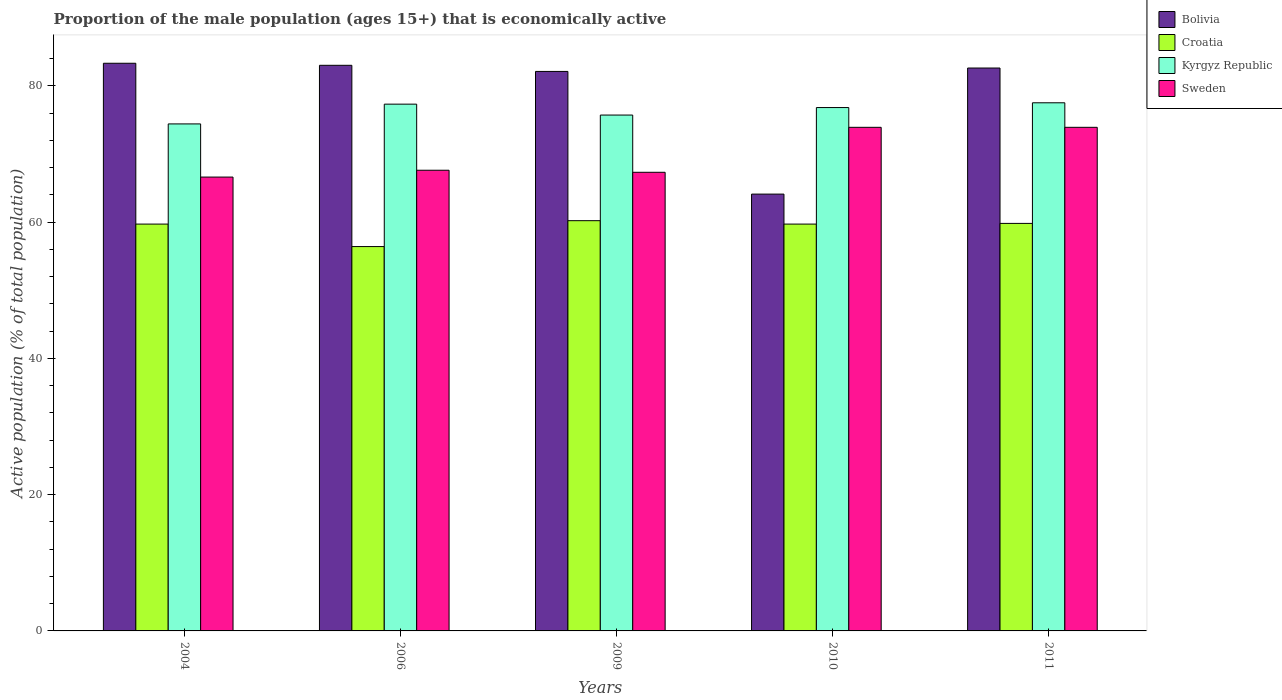How many groups of bars are there?
Offer a terse response. 5. Are the number of bars per tick equal to the number of legend labels?
Your answer should be very brief. Yes. What is the label of the 4th group of bars from the left?
Offer a terse response. 2010. In how many cases, is the number of bars for a given year not equal to the number of legend labels?
Your answer should be compact. 0. What is the proportion of the male population that is economically active in Kyrgyz Republic in 2004?
Provide a short and direct response. 74.4. Across all years, what is the maximum proportion of the male population that is economically active in Kyrgyz Republic?
Your response must be concise. 77.5. Across all years, what is the minimum proportion of the male population that is economically active in Bolivia?
Your answer should be very brief. 64.1. In which year was the proportion of the male population that is economically active in Sweden maximum?
Offer a terse response. 2010. What is the total proportion of the male population that is economically active in Sweden in the graph?
Offer a very short reply. 349.3. What is the difference between the proportion of the male population that is economically active in Bolivia in 2010 and that in 2011?
Provide a short and direct response. -18.5. What is the difference between the proportion of the male population that is economically active in Croatia in 2010 and the proportion of the male population that is economically active in Bolivia in 2009?
Your answer should be compact. -22.4. What is the average proportion of the male population that is economically active in Sweden per year?
Provide a succinct answer. 69.86. In the year 2011, what is the difference between the proportion of the male population that is economically active in Croatia and proportion of the male population that is economically active in Bolivia?
Ensure brevity in your answer.  -22.8. In how many years, is the proportion of the male population that is economically active in Croatia greater than 16 %?
Your answer should be very brief. 5. What is the ratio of the proportion of the male population that is economically active in Bolivia in 2004 to that in 2006?
Provide a succinct answer. 1. Is the difference between the proportion of the male population that is economically active in Croatia in 2004 and 2006 greater than the difference between the proportion of the male population that is economically active in Bolivia in 2004 and 2006?
Your answer should be very brief. Yes. What is the difference between the highest and the second highest proportion of the male population that is economically active in Kyrgyz Republic?
Offer a very short reply. 0.2. What is the difference between the highest and the lowest proportion of the male population that is economically active in Croatia?
Offer a very short reply. 3.8. Is it the case that in every year, the sum of the proportion of the male population that is economically active in Croatia and proportion of the male population that is economically active in Bolivia is greater than the sum of proportion of the male population that is economically active in Kyrgyz Republic and proportion of the male population that is economically active in Sweden?
Provide a succinct answer. No. What does the 3rd bar from the left in 2006 represents?
Your response must be concise. Kyrgyz Republic. What does the 3rd bar from the right in 2006 represents?
Keep it short and to the point. Croatia. Are all the bars in the graph horizontal?
Provide a short and direct response. No. How many years are there in the graph?
Provide a short and direct response. 5. Does the graph contain any zero values?
Make the answer very short. No. Where does the legend appear in the graph?
Your answer should be compact. Top right. How many legend labels are there?
Provide a succinct answer. 4. How are the legend labels stacked?
Your answer should be very brief. Vertical. What is the title of the graph?
Provide a short and direct response. Proportion of the male population (ages 15+) that is economically active. What is the label or title of the X-axis?
Provide a succinct answer. Years. What is the label or title of the Y-axis?
Make the answer very short. Active population (% of total population). What is the Active population (% of total population) of Bolivia in 2004?
Offer a terse response. 83.3. What is the Active population (% of total population) of Croatia in 2004?
Your answer should be very brief. 59.7. What is the Active population (% of total population) in Kyrgyz Republic in 2004?
Provide a short and direct response. 74.4. What is the Active population (% of total population) in Sweden in 2004?
Keep it short and to the point. 66.6. What is the Active population (% of total population) of Bolivia in 2006?
Offer a terse response. 83. What is the Active population (% of total population) of Croatia in 2006?
Your answer should be very brief. 56.4. What is the Active population (% of total population) of Kyrgyz Republic in 2006?
Offer a very short reply. 77.3. What is the Active population (% of total population) of Sweden in 2006?
Ensure brevity in your answer.  67.6. What is the Active population (% of total population) of Bolivia in 2009?
Provide a short and direct response. 82.1. What is the Active population (% of total population) in Croatia in 2009?
Your response must be concise. 60.2. What is the Active population (% of total population) of Kyrgyz Republic in 2009?
Provide a short and direct response. 75.7. What is the Active population (% of total population) in Sweden in 2009?
Provide a succinct answer. 67.3. What is the Active population (% of total population) in Bolivia in 2010?
Your answer should be very brief. 64.1. What is the Active population (% of total population) of Croatia in 2010?
Provide a succinct answer. 59.7. What is the Active population (% of total population) of Kyrgyz Republic in 2010?
Keep it short and to the point. 76.8. What is the Active population (% of total population) of Sweden in 2010?
Offer a terse response. 73.9. What is the Active population (% of total population) of Bolivia in 2011?
Ensure brevity in your answer.  82.6. What is the Active population (% of total population) of Croatia in 2011?
Your response must be concise. 59.8. What is the Active population (% of total population) of Kyrgyz Republic in 2011?
Make the answer very short. 77.5. What is the Active population (% of total population) in Sweden in 2011?
Your answer should be very brief. 73.9. Across all years, what is the maximum Active population (% of total population) of Bolivia?
Provide a short and direct response. 83.3. Across all years, what is the maximum Active population (% of total population) in Croatia?
Your answer should be very brief. 60.2. Across all years, what is the maximum Active population (% of total population) in Kyrgyz Republic?
Ensure brevity in your answer.  77.5. Across all years, what is the maximum Active population (% of total population) in Sweden?
Make the answer very short. 73.9. Across all years, what is the minimum Active population (% of total population) in Bolivia?
Your answer should be compact. 64.1. Across all years, what is the minimum Active population (% of total population) of Croatia?
Ensure brevity in your answer.  56.4. Across all years, what is the minimum Active population (% of total population) in Kyrgyz Republic?
Keep it short and to the point. 74.4. Across all years, what is the minimum Active population (% of total population) in Sweden?
Your response must be concise. 66.6. What is the total Active population (% of total population) of Bolivia in the graph?
Your answer should be compact. 395.1. What is the total Active population (% of total population) in Croatia in the graph?
Your response must be concise. 295.8. What is the total Active population (% of total population) of Kyrgyz Republic in the graph?
Ensure brevity in your answer.  381.7. What is the total Active population (% of total population) in Sweden in the graph?
Make the answer very short. 349.3. What is the difference between the Active population (% of total population) in Bolivia in 2004 and that in 2006?
Provide a short and direct response. 0.3. What is the difference between the Active population (% of total population) in Bolivia in 2004 and that in 2009?
Your answer should be very brief. 1.2. What is the difference between the Active population (% of total population) of Croatia in 2004 and that in 2009?
Offer a terse response. -0.5. What is the difference between the Active population (% of total population) of Kyrgyz Republic in 2004 and that in 2009?
Your answer should be compact. -1.3. What is the difference between the Active population (% of total population) in Bolivia in 2004 and that in 2010?
Your answer should be very brief. 19.2. What is the difference between the Active population (% of total population) of Kyrgyz Republic in 2004 and that in 2010?
Keep it short and to the point. -2.4. What is the difference between the Active population (% of total population) in Sweden in 2004 and that in 2010?
Make the answer very short. -7.3. What is the difference between the Active population (% of total population) of Croatia in 2004 and that in 2011?
Give a very brief answer. -0.1. What is the difference between the Active population (% of total population) in Croatia in 2006 and that in 2009?
Keep it short and to the point. -3.8. What is the difference between the Active population (% of total population) of Kyrgyz Republic in 2006 and that in 2010?
Your response must be concise. 0.5. What is the difference between the Active population (% of total population) of Sweden in 2006 and that in 2010?
Ensure brevity in your answer.  -6.3. What is the difference between the Active population (% of total population) in Bolivia in 2006 and that in 2011?
Your answer should be very brief. 0.4. What is the difference between the Active population (% of total population) in Kyrgyz Republic in 2006 and that in 2011?
Offer a terse response. -0.2. What is the difference between the Active population (% of total population) of Sweden in 2006 and that in 2011?
Offer a very short reply. -6.3. What is the difference between the Active population (% of total population) of Bolivia in 2009 and that in 2010?
Give a very brief answer. 18. What is the difference between the Active population (% of total population) of Kyrgyz Republic in 2009 and that in 2010?
Your answer should be very brief. -1.1. What is the difference between the Active population (% of total population) in Croatia in 2009 and that in 2011?
Give a very brief answer. 0.4. What is the difference between the Active population (% of total population) in Bolivia in 2010 and that in 2011?
Offer a terse response. -18.5. What is the difference between the Active population (% of total population) in Bolivia in 2004 and the Active population (% of total population) in Croatia in 2006?
Your response must be concise. 26.9. What is the difference between the Active population (% of total population) of Bolivia in 2004 and the Active population (% of total population) of Kyrgyz Republic in 2006?
Provide a succinct answer. 6. What is the difference between the Active population (% of total population) of Bolivia in 2004 and the Active population (% of total population) of Sweden in 2006?
Offer a terse response. 15.7. What is the difference between the Active population (% of total population) in Croatia in 2004 and the Active population (% of total population) in Kyrgyz Republic in 2006?
Provide a short and direct response. -17.6. What is the difference between the Active population (% of total population) of Bolivia in 2004 and the Active population (% of total population) of Croatia in 2009?
Provide a short and direct response. 23.1. What is the difference between the Active population (% of total population) in Bolivia in 2004 and the Active population (% of total population) in Sweden in 2009?
Your response must be concise. 16. What is the difference between the Active population (% of total population) in Croatia in 2004 and the Active population (% of total population) in Kyrgyz Republic in 2009?
Ensure brevity in your answer.  -16. What is the difference between the Active population (% of total population) of Croatia in 2004 and the Active population (% of total population) of Sweden in 2009?
Provide a short and direct response. -7.6. What is the difference between the Active population (% of total population) in Bolivia in 2004 and the Active population (% of total population) in Croatia in 2010?
Offer a terse response. 23.6. What is the difference between the Active population (% of total population) in Bolivia in 2004 and the Active population (% of total population) in Kyrgyz Republic in 2010?
Provide a short and direct response. 6.5. What is the difference between the Active population (% of total population) in Croatia in 2004 and the Active population (% of total population) in Kyrgyz Republic in 2010?
Offer a terse response. -17.1. What is the difference between the Active population (% of total population) in Kyrgyz Republic in 2004 and the Active population (% of total population) in Sweden in 2010?
Keep it short and to the point. 0.5. What is the difference between the Active population (% of total population) of Bolivia in 2004 and the Active population (% of total population) of Croatia in 2011?
Offer a terse response. 23.5. What is the difference between the Active population (% of total population) in Bolivia in 2004 and the Active population (% of total population) in Kyrgyz Republic in 2011?
Keep it short and to the point. 5.8. What is the difference between the Active population (% of total population) of Bolivia in 2004 and the Active population (% of total population) of Sweden in 2011?
Your answer should be compact. 9.4. What is the difference between the Active population (% of total population) of Croatia in 2004 and the Active population (% of total population) of Kyrgyz Republic in 2011?
Your answer should be very brief. -17.8. What is the difference between the Active population (% of total population) of Kyrgyz Republic in 2004 and the Active population (% of total population) of Sweden in 2011?
Give a very brief answer. 0.5. What is the difference between the Active population (% of total population) in Bolivia in 2006 and the Active population (% of total population) in Croatia in 2009?
Provide a succinct answer. 22.8. What is the difference between the Active population (% of total population) in Bolivia in 2006 and the Active population (% of total population) in Sweden in 2009?
Keep it short and to the point. 15.7. What is the difference between the Active population (% of total population) of Croatia in 2006 and the Active population (% of total population) of Kyrgyz Republic in 2009?
Your answer should be very brief. -19.3. What is the difference between the Active population (% of total population) in Bolivia in 2006 and the Active population (% of total population) in Croatia in 2010?
Keep it short and to the point. 23.3. What is the difference between the Active population (% of total population) in Bolivia in 2006 and the Active population (% of total population) in Sweden in 2010?
Your answer should be very brief. 9.1. What is the difference between the Active population (% of total population) of Croatia in 2006 and the Active population (% of total population) of Kyrgyz Republic in 2010?
Your answer should be very brief. -20.4. What is the difference between the Active population (% of total population) of Croatia in 2006 and the Active population (% of total population) of Sweden in 2010?
Your answer should be compact. -17.5. What is the difference between the Active population (% of total population) in Kyrgyz Republic in 2006 and the Active population (% of total population) in Sweden in 2010?
Give a very brief answer. 3.4. What is the difference between the Active population (% of total population) of Bolivia in 2006 and the Active population (% of total population) of Croatia in 2011?
Your answer should be very brief. 23.2. What is the difference between the Active population (% of total population) of Bolivia in 2006 and the Active population (% of total population) of Kyrgyz Republic in 2011?
Provide a succinct answer. 5.5. What is the difference between the Active population (% of total population) in Bolivia in 2006 and the Active population (% of total population) in Sweden in 2011?
Give a very brief answer. 9.1. What is the difference between the Active population (% of total population) of Croatia in 2006 and the Active population (% of total population) of Kyrgyz Republic in 2011?
Give a very brief answer. -21.1. What is the difference between the Active population (% of total population) in Croatia in 2006 and the Active population (% of total population) in Sweden in 2011?
Give a very brief answer. -17.5. What is the difference between the Active population (% of total population) of Kyrgyz Republic in 2006 and the Active population (% of total population) of Sweden in 2011?
Give a very brief answer. 3.4. What is the difference between the Active population (% of total population) in Bolivia in 2009 and the Active population (% of total population) in Croatia in 2010?
Offer a terse response. 22.4. What is the difference between the Active population (% of total population) of Bolivia in 2009 and the Active population (% of total population) of Kyrgyz Republic in 2010?
Your response must be concise. 5.3. What is the difference between the Active population (% of total population) of Bolivia in 2009 and the Active population (% of total population) of Sweden in 2010?
Your response must be concise. 8.2. What is the difference between the Active population (% of total population) in Croatia in 2009 and the Active population (% of total population) in Kyrgyz Republic in 2010?
Ensure brevity in your answer.  -16.6. What is the difference between the Active population (% of total population) of Croatia in 2009 and the Active population (% of total population) of Sweden in 2010?
Give a very brief answer. -13.7. What is the difference between the Active population (% of total population) in Bolivia in 2009 and the Active population (% of total population) in Croatia in 2011?
Offer a terse response. 22.3. What is the difference between the Active population (% of total population) in Croatia in 2009 and the Active population (% of total population) in Kyrgyz Republic in 2011?
Your response must be concise. -17.3. What is the difference between the Active population (% of total population) in Croatia in 2009 and the Active population (% of total population) in Sweden in 2011?
Offer a terse response. -13.7. What is the difference between the Active population (% of total population) in Kyrgyz Republic in 2009 and the Active population (% of total population) in Sweden in 2011?
Your answer should be compact. 1.8. What is the difference between the Active population (% of total population) of Bolivia in 2010 and the Active population (% of total population) of Croatia in 2011?
Keep it short and to the point. 4.3. What is the difference between the Active population (% of total population) in Bolivia in 2010 and the Active population (% of total population) in Kyrgyz Republic in 2011?
Your answer should be compact. -13.4. What is the difference between the Active population (% of total population) in Bolivia in 2010 and the Active population (% of total population) in Sweden in 2011?
Keep it short and to the point. -9.8. What is the difference between the Active population (% of total population) in Croatia in 2010 and the Active population (% of total population) in Kyrgyz Republic in 2011?
Your response must be concise. -17.8. What is the difference between the Active population (% of total population) in Croatia in 2010 and the Active population (% of total population) in Sweden in 2011?
Give a very brief answer. -14.2. What is the average Active population (% of total population) of Bolivia per year?
Your answer should be very brief. 79.02. What is the average Active population (% of total population) in Croatia per year?
Provide a short and direct response. 59.16. What is the average Active population (% of total population) in Kyrgyz Republic per year?
Offer a very short reply. 76.34. What is the average Active population (% of total population) in Sweden per year?
Your answer should be very brief. 69.86. In the year 2004, what is the difference between the Active population (% of total population) of Bolivia and Active population (% of total population) of Croatia?
Provide a short and direct response. 23.6. In the year 2004, what is the difference between the Active population (% of total population) of Croatia and Active population (% of total population) of Kyrgyz Republic?
Provide a short and direct response. -14.7. In the year 2004, what is the difference between the Active population (% of total population) of Croatia and Active population (% of total population) of Sweden?
Provide a succinct answer. -6.9. In the year 2006, what is the difference between the Active population (% of total population) of Bolivia and Active population (% of total population) of Croatia?
Provide a succinct answer. 26.6. In the year 2006, what is the difference between the Active population (% of total population) of Croatia and Active population (% of total population) of Kyrgyz Republic?
Keep it short and to the point. -20.9. In the year 2006, what is the difference between the Active population (% of total population) in Croatia and Active population (% of total population) in Sweden?
Offer a very short reply. -11.2. In the year 2006, what is the difference between the Active population (% of total population) in Kyrgyz Republic and Active population (% of total population) in Sweden?
Give a very brief answer. 9.7. In the year 2009, what is the difference between the Active population (% of total population) in Bolivia and Active population (% of total population) in Croatia?
Your answer should be very brief. 21.9. In the year 2009, what is the difference between the Active population (% of total population) in Bolivia and Active population (% of total population) in Kyrgyz Republic?
Keep it short and to the point. 6.4. In the year 2009, what is the difference between the Active population (% of total population) of Bolivia and Active population (% of total population) of Sweden?
Give a very brief answer. 14.8. In the year 2009, what is the difference between the Active population (% of total population) of Croatia and Active population (% of total population) of Kyrgyz Republic?
Ensure brevity in your answer.  -15.5. In the year 2009, what is the difference between the Active population (% of total population) in Croatia and Active population (% of total population) in Sweden?
Provide a short and direct response. -7.1. In the year 2010, what is the difference between the Active population (% of total population) in Bolivia and Active population (% of total population) in Croatia?
Your answer should be compact. 4.4. In the year 2010, what is the difference between the Active population (% of total population) of Bolivia and Active population (% of total population) of Kyrgyz Republic?
Keep it short and to the point. -12.7. In the year 2010, what is the difference between the Active population (% of total population) of Croatia and Active population (% of total population) of Kyrgyz Republic?
Ensure brevity in your answer.  -17.1. In the year 2011, what is the difference between the Active population (% of total population) of Bolivia and Active population (% of total population) of Croatia?
Offer a very short reply. 22.8. In the year 2011, what is the difference between the Active population (% of total population) of Croatia and Active population (% of total population) of Kyrgyz Republic?
Give a very brief answer. -17.7. In the year 2011, what is the difference between the Active population (% of total population) of Croatia and Active population (% of total population) of Sweden?
Offer a very short reply. -14.1. What is the ratio of the Active population (% of total population) in Croatia in 2004 to that in 2006?
Provide a short and direct response. 1.06. What is the ratio of the Active population (% of total population) of Kyrgyz Republic in 2004 to that in 2006?
Keep it short and to the point. 0.96. What is the ratio of the Active population (% of total population) of Sweden in 2004 to that in 2006?
Make the answer very short. 0.99. What is the ratio of the Active population (% of total population) in Bolivia in 2004 to that in 2009?
Provide a short and direct response. 1.01. What is the ratio of the Active population (% of total population) of Croatia in 2004 to that in 2009?
Offer a terse response. 0.99. What is the ratio of the Active population (% of total population) in Kyrgyz Republic in 2004 to that in 2009?
Give a very brief answer. 0.98. What is the ratio of the Active population (% of total population) of Sweden in 2004 to that in 2009?
Your answer should be very brief. 0.99. What is the ratio of the Active population (% of total population) of Bolivia in 2004 to that in 2010?
Your answer should be compact. 1.3. What is the ratio of the Active population (% of total population) of Croatia in 2004 to that in 2010?
Offer a terse response. 1. What is the ratio of the Active population (% of total population) in Kyrgyz Republic in 2004 to that in 2010?
Keep it short and to the point. 0.97. What is the ratio of the Active population (% of total population) of Sweden in 2004 to that in 2010?
Provide a short and direct response. 0.9. What is the ratio of the Active population (% of total population) of Bolivia in 2004 to that in 2011?
Offer a very short reply. 1.01. What is the ratio of the Active population (% of total population) in Kyrgyz Republic in 2004 to that in 2011?
Offer a terse response. 0.96. What is the ratio of the Active population (% of total population) of Sweden in 2004 to that in 2011?
Your response must be concise. 0.9. What is the ratio of the Active population (% of total population) of Bolivia in 2006 to that in 2009?
Ensure brevity in your answer.  1.01. What is the ratio of the Active population (% of total population) in Croatia in 2006 to that in 2009?
Your response must be concise. 0.94. What is the ratio of the Active population (% of total population) of Kyrgyz Republic in 2006 to that in 2009?
Make the answer very short. 1.02. What is the ratio of the Active population (% of total population) of Sweden in 2006 to that in 2009?
Offer a terse response. 1. What is the ratio of the Active population (% of total population) in Bolivia in 2006 to that in 2010?
Your response must be concise. 1.29. What is the ratio of the Active population (% of total population) of Croatia in 2006 to that in 2010?
Offer a very short reply. 0.94. What is the ratio of the Active population (% of total population) in Sweden in 2006 to that in 2010?
Offer a terse response. 0.91. What is the ratio of the Active population (% of total population) of Croatia in 2006 to that in 2011?
Your answer should be compact. 0.94. What is the ratio of the Active population (% of total population) in Kyrgyz Republic in 2006 to that in 2011?
Make the answer very short. 1. What is the ratio of the Active population (% of total population) in Sweden in 2006 to that in 2011?
Your answer should be very brief. 0.91. What is the ratio of the Active population (% of total population) of Bolivia in 2009 to that in 2010?
Your answer should be compact. 1.28. What is the ratio of the Active population (% of total population) in Croatia in 2009 to that in 2010?
Provide a succinct answer. 1.01. What is the ratio of the Active population (% of total population) of Kyrgyz Republic in 2009 to that in 2010?
Ensure brevity in your answer.  0.99. What is the ratio of the Active population (% of total population) in Sweden in 2009 to that in 2010?
Your response must be concise. 0.91. What is the ratio of the Active population (% of total population) in Bolivia in 2009 to that in 2011?
Your response must be concise. 0.99. What is the ratio of the Active population (% of total population) of Croatia in 2009 to that in 2011?
Offer a terse response. 1.01. What is the ratio of the Active population (% of total population) in Kyrgyz Republic in 2009 to that in 2011?
Your answer should be compact. 0.98. What is the ratio of the Active population (% of total population) of Sweden in 2009 to that in 2011?
Ensure brevity in your answer.  0.91. What is the ratio of the Active population (% of total population) in Bolivia in 2010 to that in 2011?
Make the answer very short. 0.78. What is the ratio of the Active population (% of total population) of Croatia in 2010 to that in 2011?
Your response must be concise. 1. What is the ratio of the Active population (% of total population) of Kyrgyz Republic in 2010 to that in 2011?
Offer a terse response. 0.99. What is the ratio of the Active population (% of total population) of Sweden in 2010 to that in 2011?
Provide a short and direct response. 1. What is the difference between the highest and the second highest Active population (% of total population) of Bolivia?
Make the answer very short. 0.3. What is the difference between the highest and the second highest Active population (% of total population) in Croatia?
Keep it short and to the point. 0.4. What is the difference between the highest and the second highest Active population (% of total population) in Sweden?
Your answer should be compact. 0. What is the difference between the highest and the lowest Active population (% of total population) of Kyrgyz Republic?
Make the answer very short. 3.1. 